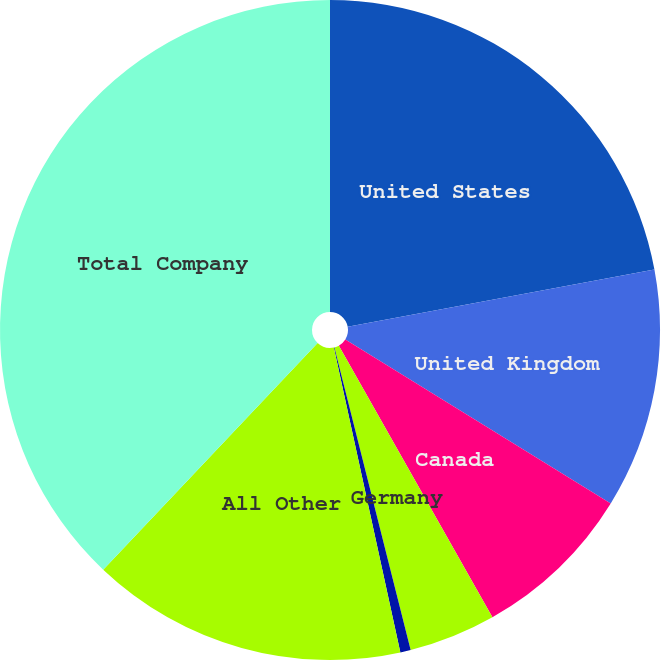Convert chart to OTSL. <chart><loc_0><loc_0><loc_500><loc_500><pie_chart><fcel>United States<fcel>United Kingdom<fcel>Canada<fcel>Germany<fcel>Mexico<fcel>All Other<fcel>Total Company<nl><fcel>22.07%<fcel>11.74%<fcel>8.0%<fcel>4.26%<fcel>0.51%<fcel>15.48%<fcel>37.94%<nl></chart> 